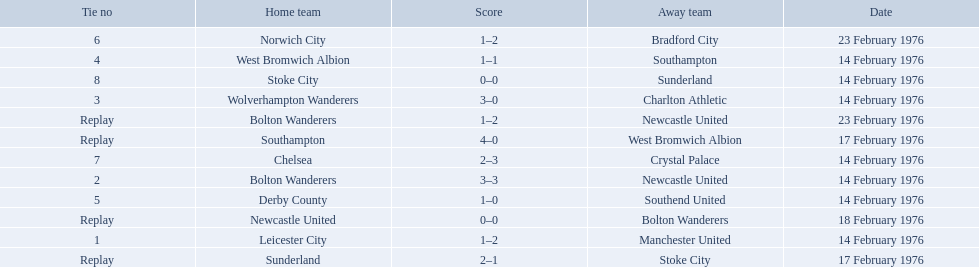Who were all of the teams? Leicester City, Manchester United, Bolton Wanderers, Newcastle United, Newcastle United, Bolton Wanderers, Bolton Wanderers, Newcastle United, Wolverhampton Wanderers, Charlton Athletic, West Bromwich Albion, Southampton, Southampton, West Bromwich Albion, Derby County, Southend United, Norwich City, Bradford City, Chelsea, Crystal Palace, Stoke City, Sunderland, Sunderland, Stoke City. And what were their scores? 1–2, 3–3, 0–0, 1–2, 3–0, 1–1, 4–0, 1–0, 1–2, 2–3, 0–0, 2–1. Between manchester and wolverhampton, who scored more? Wolverhampton Wanderers. 